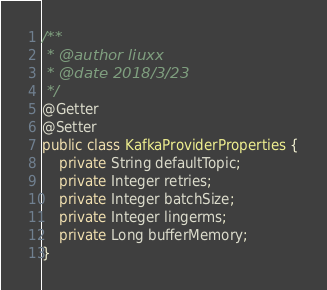Convert code to text. <code><loc_0><loc_0><loc_500><loc_500><_Java_>/**
 * @author liuxx
 * @date 2018/3/23
 */
@Getter
@Setter
public class KafkaProviderProperties {
    private String defaultTopic;
    private Integer retries;
    private Integer batchSize;
    private Integer lingerms;
    private Long bufferMemory;
}
</code> 